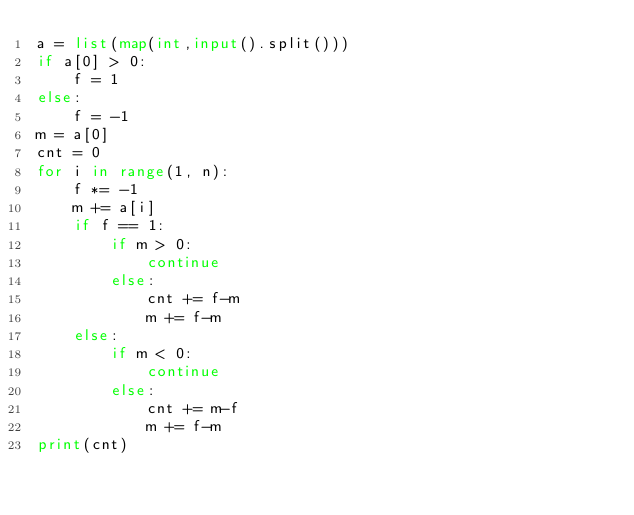<code> <loc_0><loc_0><loc_500><loc_500><_Python_>a = list(map(int,input().split()))
if a[0] > 0:
    f = 1
else:
    f = -1
m = a[0]
cnt = 0
for i in range(1, n):
    f *= -1
    m += a[i]
    if f == 1:
        if m > 0:
            continue
        else:
            cnt += f-m
            m += f-m
    else:
        if m < 0:
            continue
        else:
            cnt += m-f
            m += f-m
print(cnt)</code> 